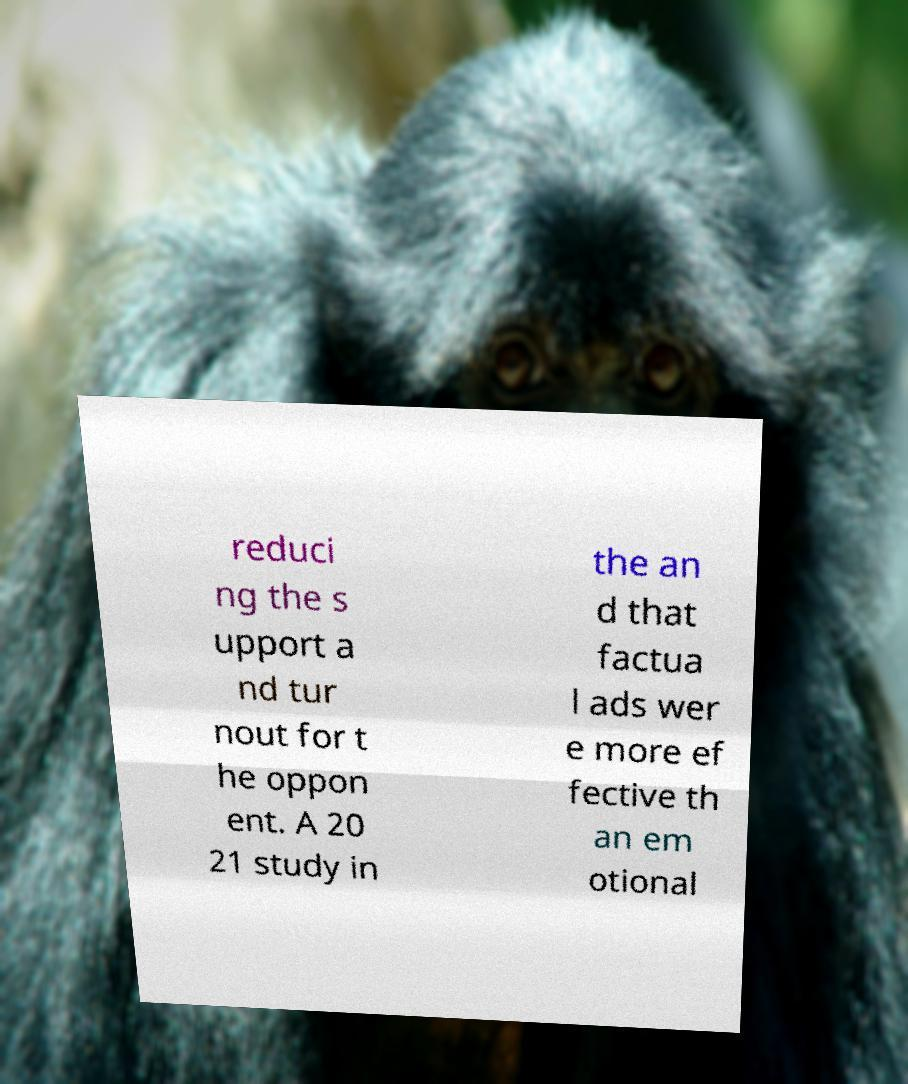Please identify and transcribe the text found in this image. reduci ng the s upport a nd tur nout for t he oppon ent. A 20 21 study in the an d that factua l ads wer e more ef fective th an em otional 